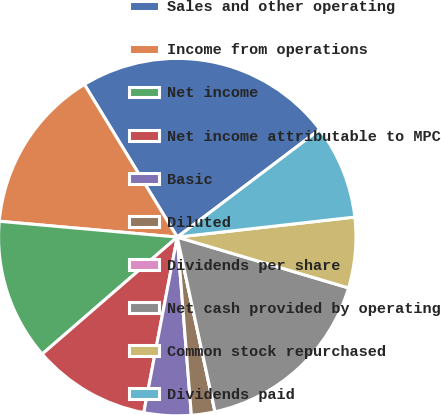<chart> <loc_0><loc_0><loc_500><loc_500><pie_chart><fcel>Sales and other operating<fcel>Income from operations<fcel>Net income<fcel>Net income attributable to MPC<fcel>Basic<fcel>Diluted<fcel>Dividends per share<fcel>Net cash provided by operating<fcel>Common stock repurchased<fcel>Dividends paid<nl><fcel>23.4%<fcel>14.89%<fcel>12.77%<fcel>10.64%<fcel>4.26%<fcel>2.13%<fcel>0.0%<fcel>17.02%<fcel>6.38%<fcel>8.51%<nl></chart> 